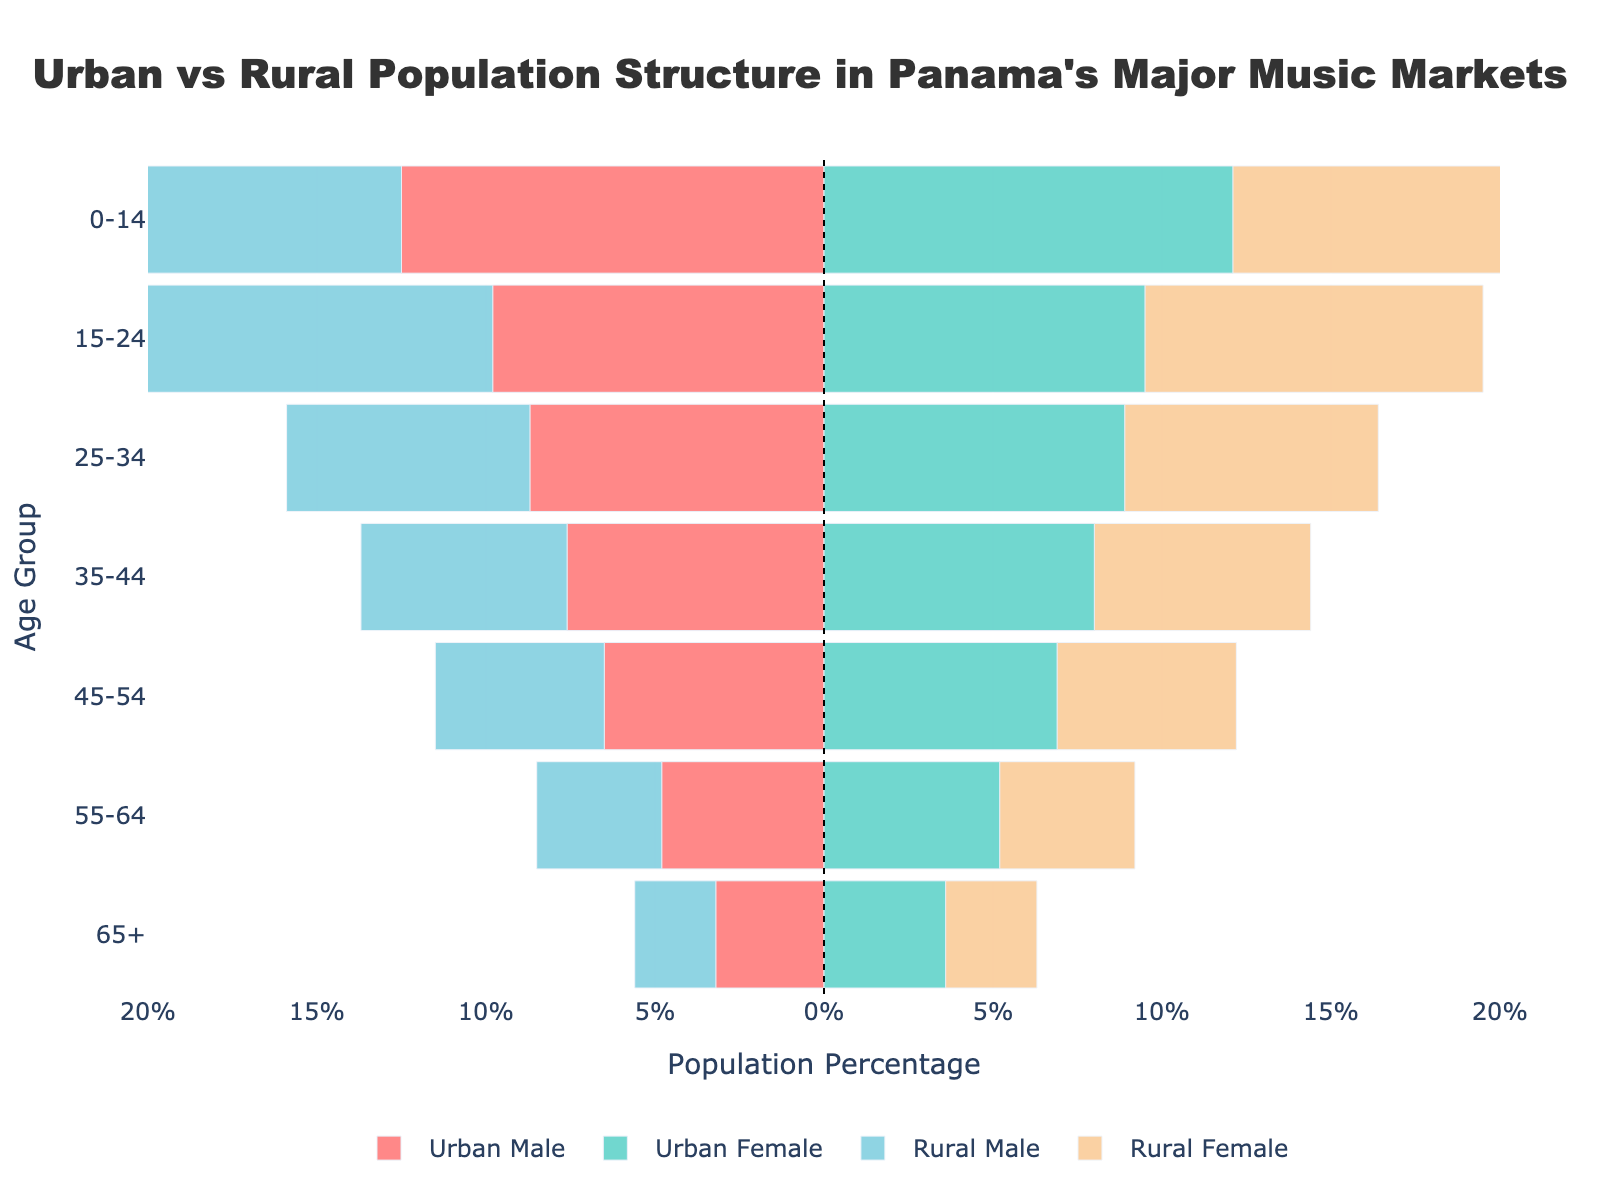What age group has the highest percentage in urban males? The age group with the highest percentage in urban males can be identified by looking at the bar with the greatest length on the negative side of the x-axis for urban males.
Answer: 0-14 What is the total percentage of the urban population between the ages of 25-34? To find the total percentage, add the percentages of urban males and urban females in the 25-34 age group: 8.7% (males) + 8.9% (females).
Answer: 17.6% Which age group sees a larger percentage of rural females compared to rural males? By observing each age group for the lengths of the bars representing rural males and females, the age group where the bar for rural females exceeds that of rural males is determined.
Answer: 0-14 How does the percentage of the 65+ urban male population compare to the rural male population of the same age group? Compare the lengths of the bars for urban males and rural males in the 65+ age group. Urban males have a percentage of 3.2% while rural males have 2.4%, hence the former is higher.
Answer: Urban male percentage is higher What is the difference in percentage between urban and rural females in the age group 45-54? Subtract the rural female percentage from the urban female percentage for the age group 45-54: 6.9% - 5.3%.
Answer: 1.6% Which gender has a higher percentage in the age group 35-44 in rural areas? Look at the lengths of the bars representing rural males and rural females in the 35-44 age group. Rural females have a higher percentage (6.4%) compared to rural males (6.1%).
Answer: Rural females Is the urban female population percentage higher or lower than the rural female population percentage in the 15-24 age group? Compare the bar lengths of urban females and rural females in the 15-24 age group. Urban females have 9.5%, while rural females have 10.0%.
Answer: Lower What is the sum of the percentages of rural males and females in the age group 55-64? Add the percentages of rural males and rural females in the age group 55-64: 3.7% (males) + 4.0% (females).
Answer: 7.7% In the 0-14 age group, do urban males or urban females make up a larger percentage of the population? Compare the urban male and female bars' lengths in the 0-14 age group. Urban males have 12.5%, which is higher than urban females with 12.1%.
Answer: Urban males Which age group shows the least percentage difference between urban and rural populations for females? Evaluate the lengths of the urban female and rural female bars for each age group to find the smallest percentage difference. The age group with the least difference is 65+, where the difference is 0.9% (3.6% - 2.7%).
Answer: 65+ 